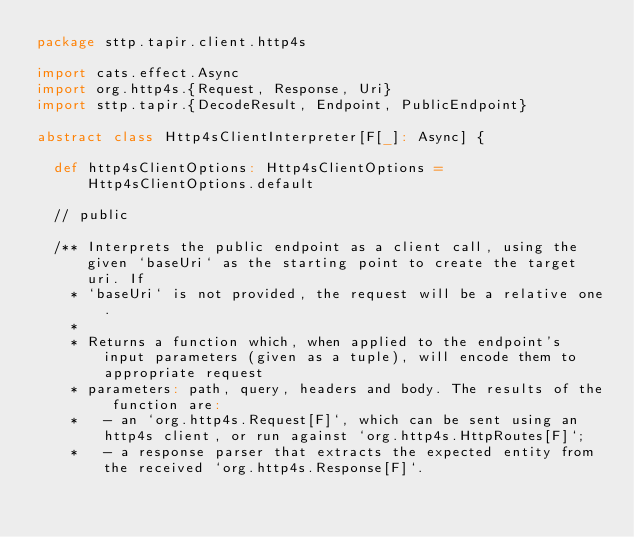Convert code to text. <code><loc_0><loc_0><loc_500><loc_500><_Scala_>package sttp.tapir.client.http4s

import cats.effect.Async
import org.http4s.{Request, Response, Uri}
import sttp.tapir.{DecodeResult, Endpoint, PublicEndpoint}

abstract class Http4sClientInterpreter[F[_]: Async] {

  def http4sClientOptions: Http4sClientOptions = Http4sClientOptions.default

  // public

  /** Interprets the public endpoint as a client call, using the given `baseUri` as the starting point to create the target uri. If
    * `baseUri` is not provided, the request will be a relative one.
    *
    * Returns a function which, when applied to the endpoint's input parameters (given as a tuple), will encode them to appropriate request
    * parameters: path, query, headers and body. The results of the function are:
    *   - an `org.http4s.Request[F]`, which can be sent using an http4s client, or run against `org.http4s.HttpRoutes[F]`;
    *   - a response parser that extracts the expected entity from the received `org.http4s.Response[F]`.</code> 